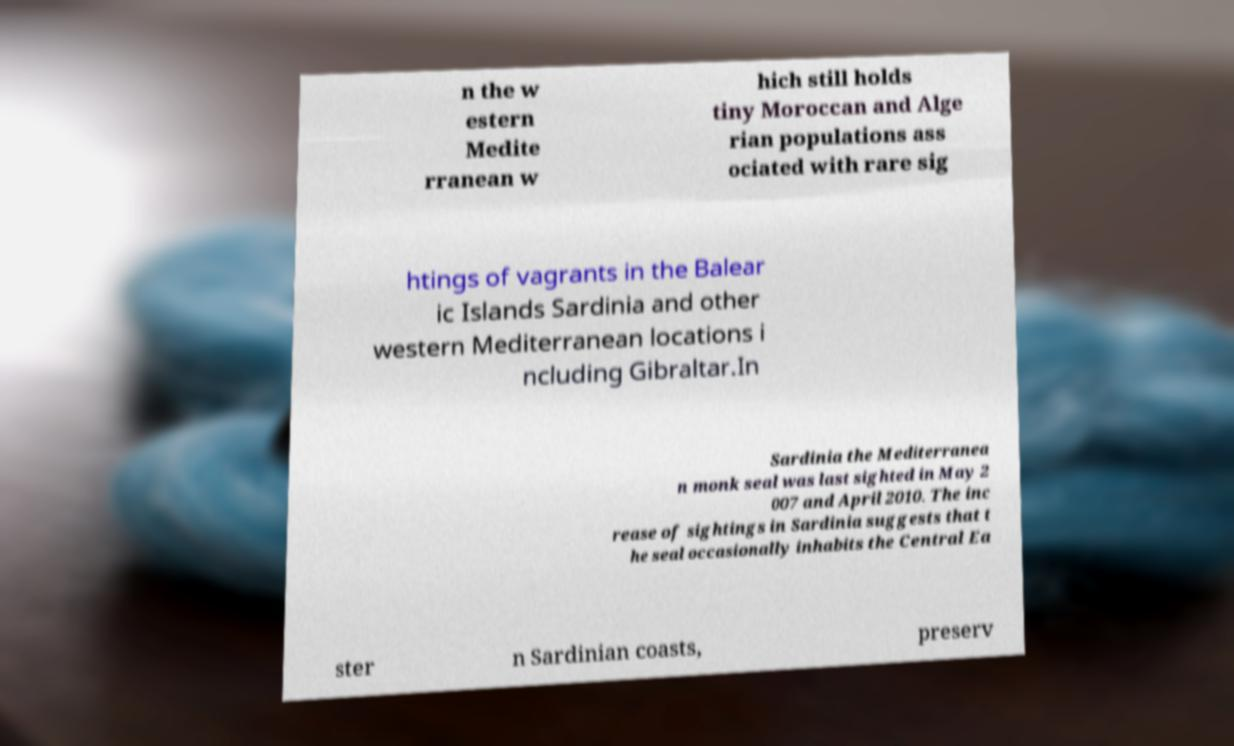For documentation purposes, I need the text within this image transcribed. Could you provide that? n the w estern Medite rranean w hich still holds tiny Moroccan and Alge rian populations ass ociated with rare sig htings of vagrants in the Balear ic Islands Sardinia and other western Mediterranean locations i ncluding Gibraltar.In Sardinia the Mediterranea n monk seal was last sighted in May 2 007 and April 2010. The inc rease of sightings in Sardinia suggests that t he seal occasionally inhabits the Central Ea ster n Sardinian coasts, preserv 